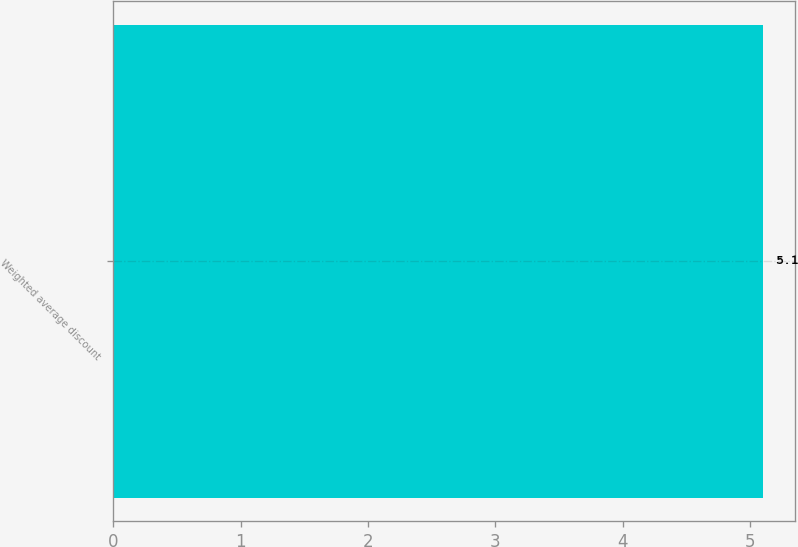Convert chart. <chart><loc_0><loc_0><loc_500><loc_500><bar_chart><fcel>Weighted average discount<nl><fcel>5.1<nl></chart> 